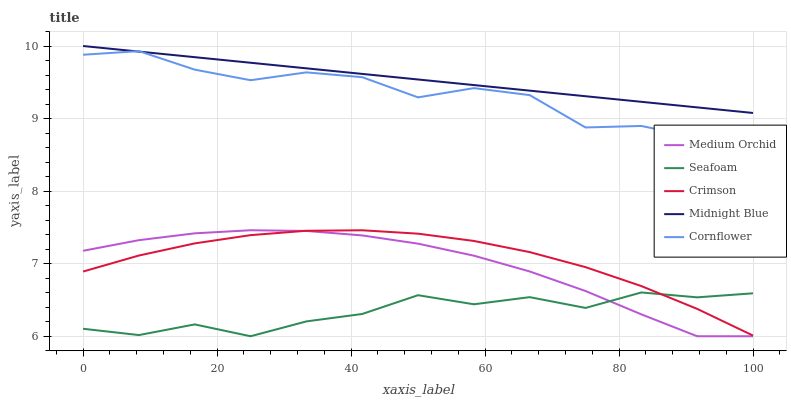Does Cornflower have the minimum area under the curve?
Answer yes or no. No. Does Cornflower have the maximum area under the curve?
Answer yes or no. No. Is Cornflower the smoothest?
Answer yes or no. No. Is Cornflower the roughest?
Answer yes or no. No. Does Cornflower have the lowest value?
Answer yes or no. No. Does Cornflower have the highest value?
Answer yes or no. No. Is Crimson less than Cornflower?
Answer yes or no. Yes. Is Midnight Blue greater than Seafoam?
Answer yes or no. Yes. Does Crimson intersect Cornflower?
Answer yes or no. No. 